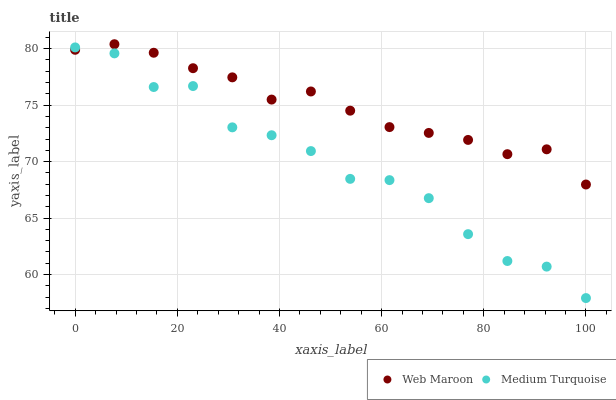Does Medium Turquoise have the minimum area under the curve?
Answer yes or no. Yes. Does Web Maroon have the maximum area under the curve?
Answer yes or no. Yes. Does Medium Turquoise have the maximum area under the curve?
Answer yes or no. No. Is Web Maroon the smoothest?
Answer yes or no. Yes. Is Medium Turquoise the roughest?
Answer yes or no. Yes. Is Medium Turquoise the smoothest?
Answer yes or no. No. Does Medium Turquoise have the lowest value?
Answer yes or no. Yes. Does Web Maroon have the highest value?
Answer yes or no. Yes. Does Medium Turquoise have the highest value?
Answer yes or no. No. Does Medium Turquoise intersect Web Maroon?
Answer yes or no. Yes. Is Medium Turquoise less than Web Maroon?
Answer yes or no. No. Is Medium Turquoise greater than Web Maroon?
Answer yes or no. No. 